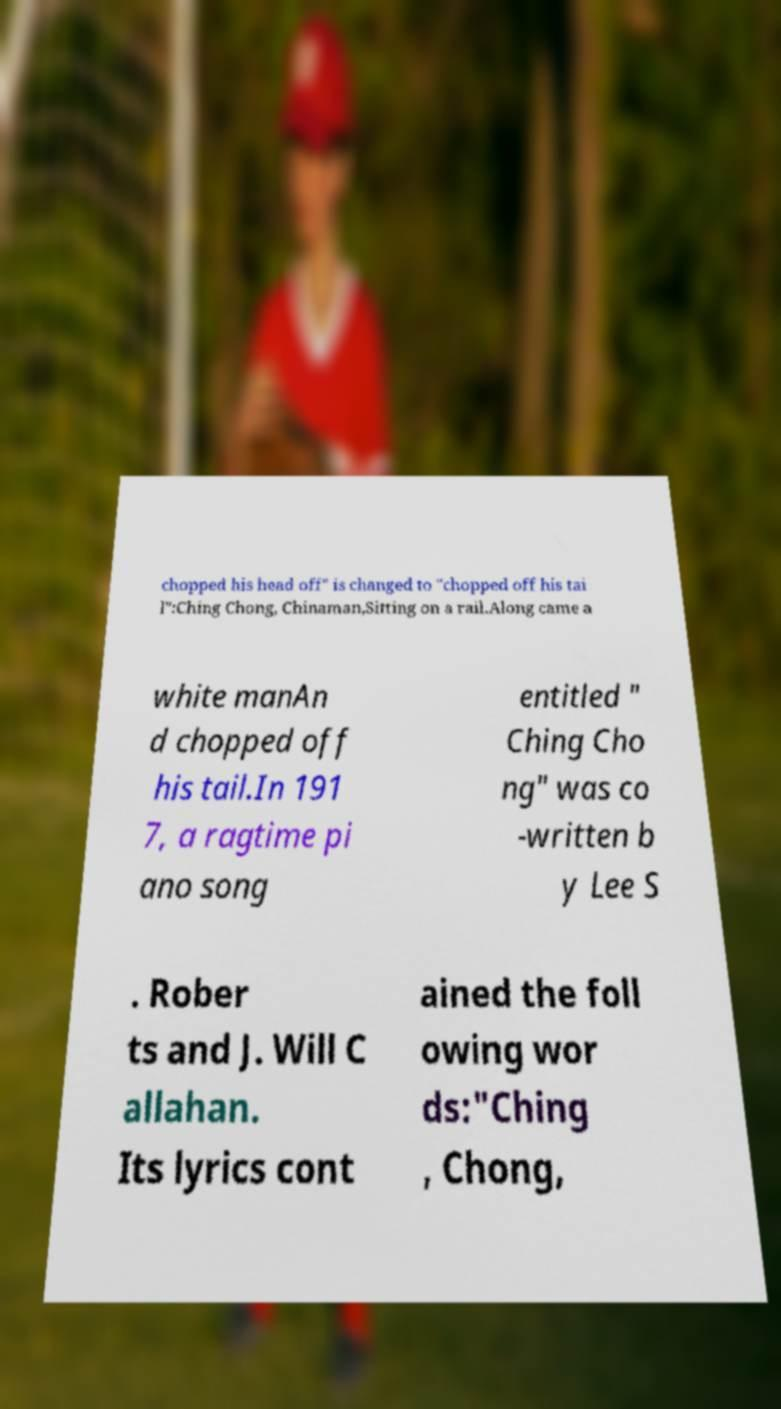Can you read and provide the text displayed in the image?This photo seems to have some interesting text. Can you extract and type it out for me? chopped his head off" is changed to "chopped off his tai l":Ching Chong, Chinaman,Sitting on a rail.Along came a white manAn d chopped off his tail.In 191 7, a ragtime pi ano song entitled " Ching Cho ng" was co -written b y Lee S . Rober ts and J. Will C allahan. Its lyrics cont ained the foll owing wor ds:"Ching , Chong, 